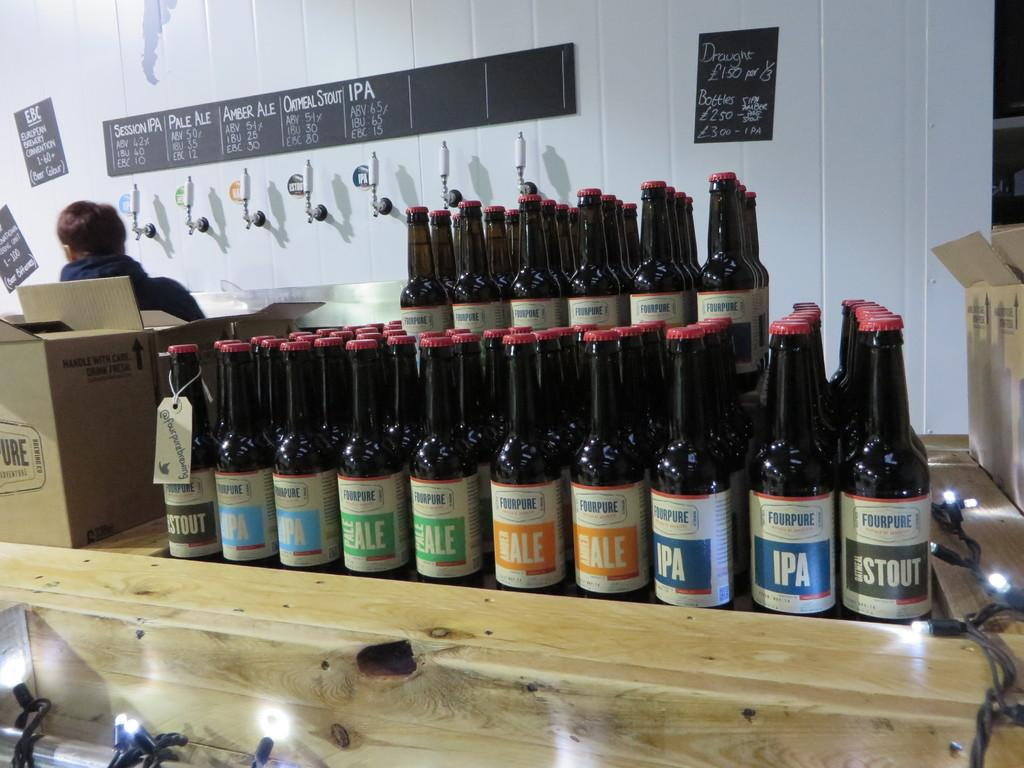<image>
Share a concise interpretation of the image provided. Several bottles of beer including some labeled IPA and STOUT 